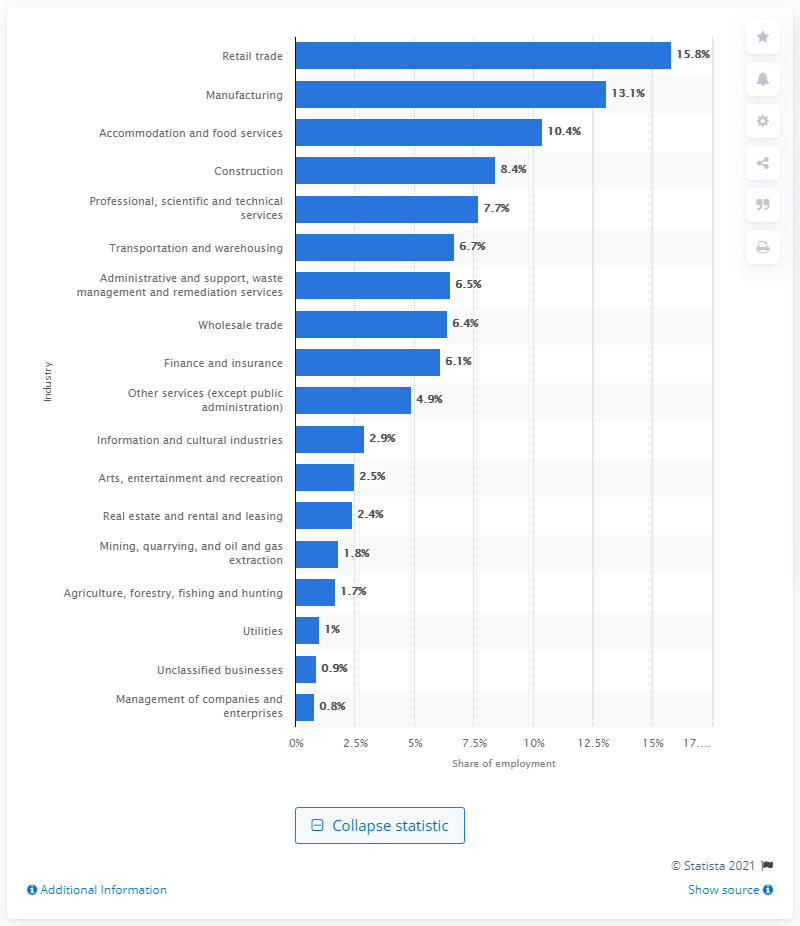Highlight a few significant elements in this photo. In 2018, 13.1% of private sector employees were employed in the manufacturing industry. 